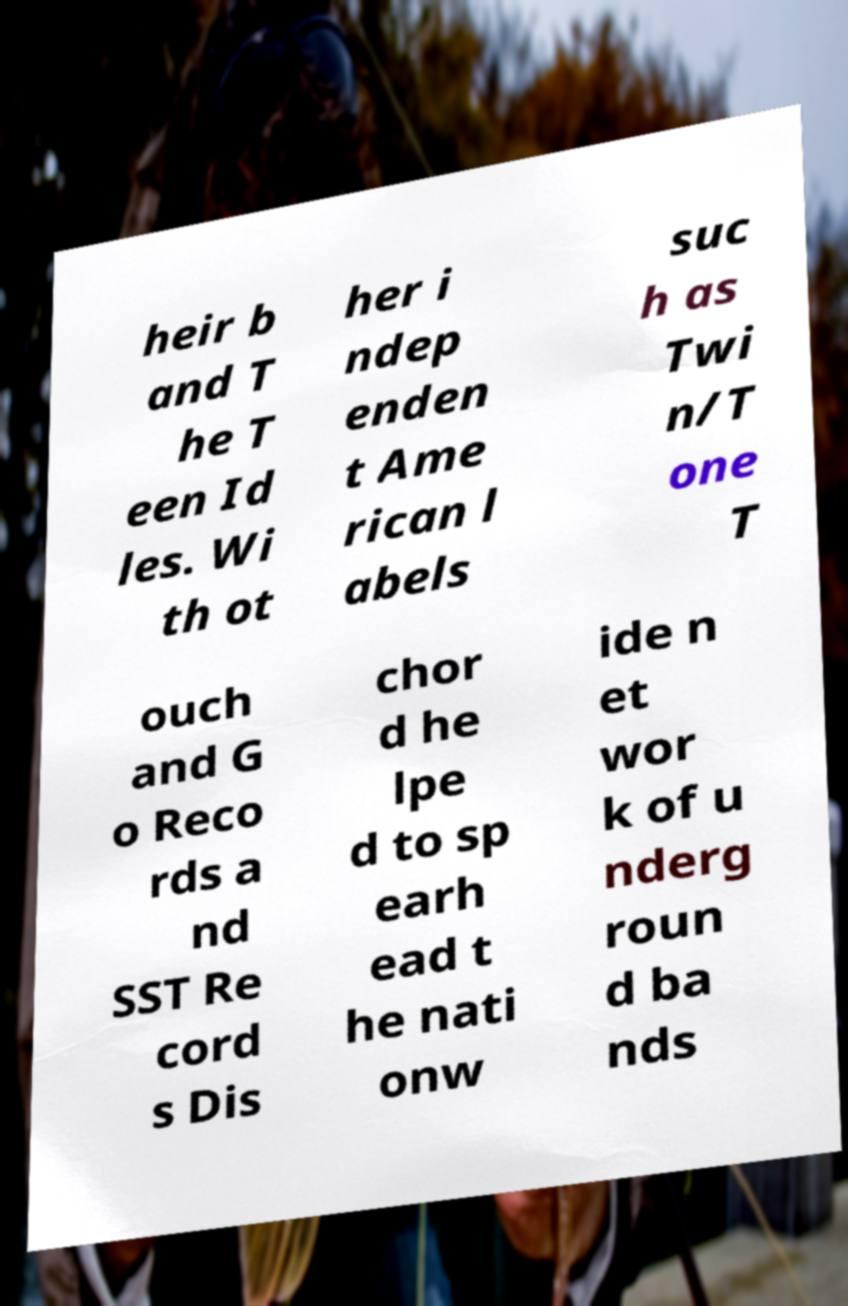There's text embedded in this image that I need extracted. Can you transcribe it verbatim? heir b and T he T een Id les. Wi th ot her i ndep enden t Ame rican l abels suc h as Twi n/T one T ouch and G o Reco rds a nd SST Re cord s Dis chor d he lpe d to sp earh ead t he nati onw ide n et wor k of u nderg roun d ba nds 